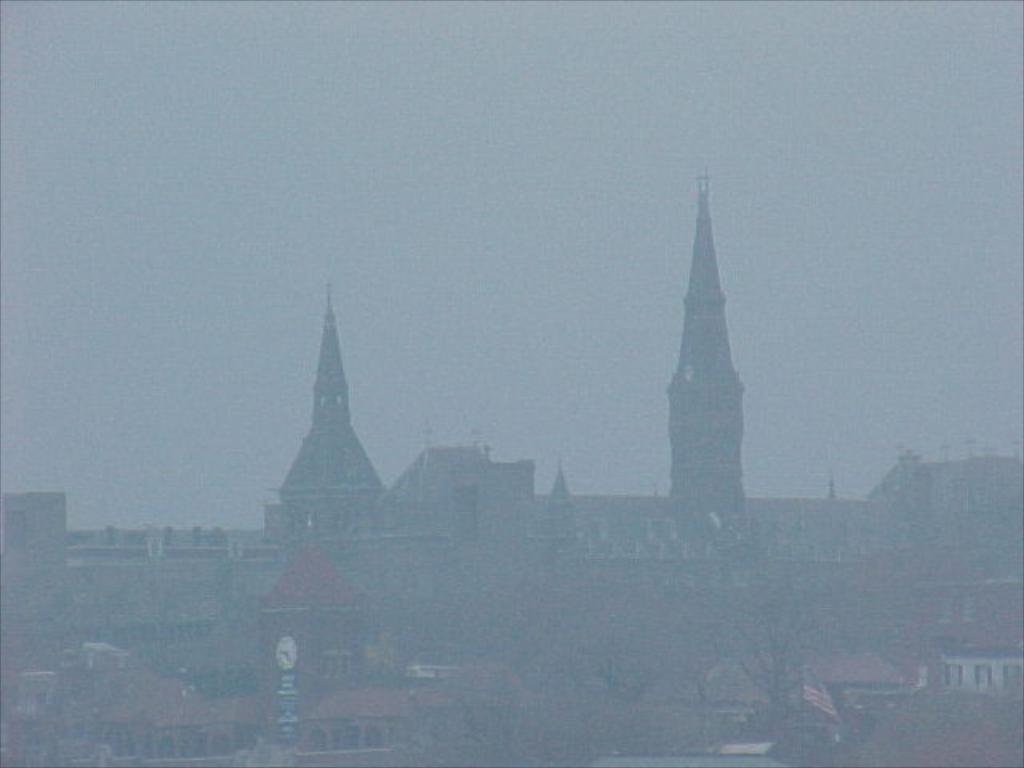Could you give a brief overview of what you see in this image? In this image we can see the buildings, windows, clock tower, trees, at the top we can see the sky. 